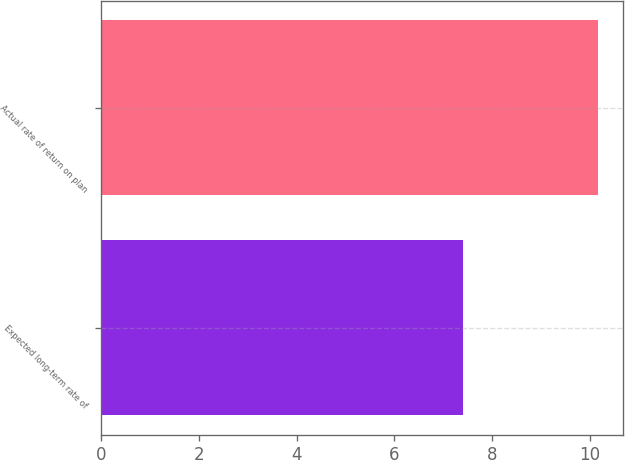<chart> <loc_0><loc_0><loc_500><loc_500><bar_chart><fcel>Expected long-term rate of<fcel>Actual rate of return on plan<nl><fcel>7.4<fcel>10.17<nl></chart> 